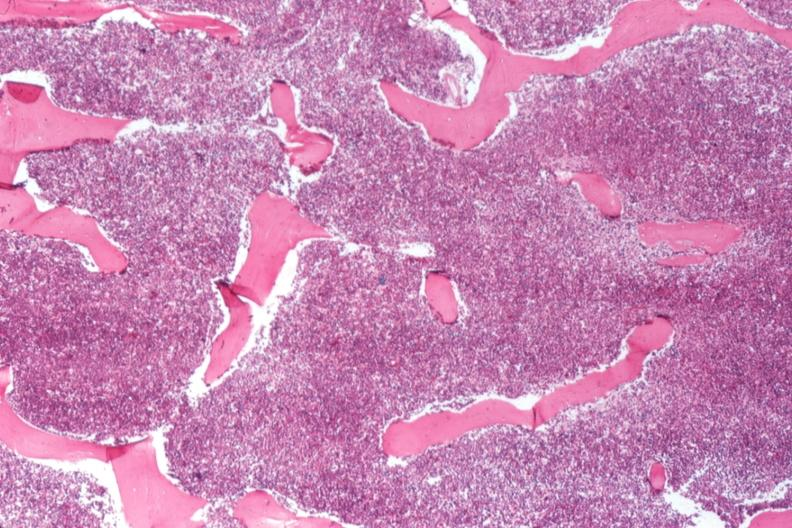what is present?
Answer the question using a single word or phrase. Hematologic 